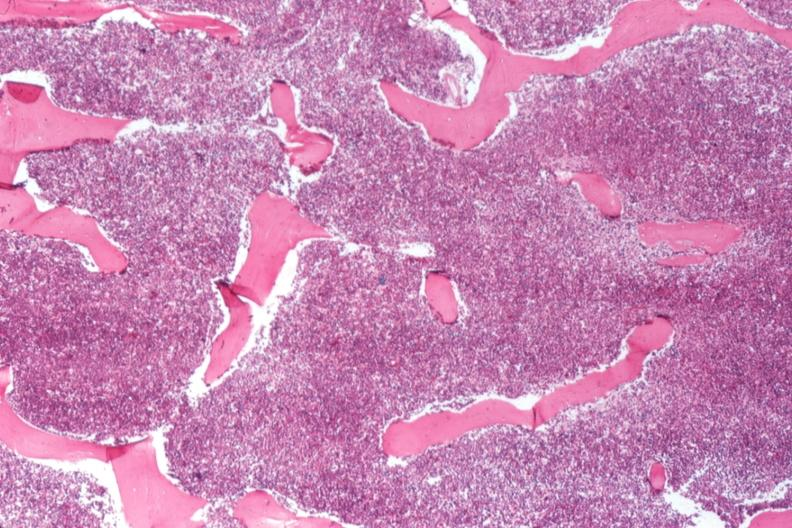what is present?
Answer the question using a single word or phrase. Hematologic 